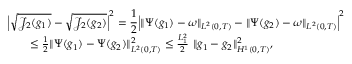Convert formula to latex. <formula><loc_0><loc_0><loc_500><loc_500>\begin{array} { r l r } { { \left | \sqrt { \mathcal { J } _ { 2 } ( g _ { 1 } ) } - \sqrt { \mathcal { J } _ { 2 } ( g _ { 2 } ) } \right | ^ { 2 } = \frac { 1 } { 2 } \left | \| \Psi ( g _ { 1 } ) - \omega \| _ { L ^ { 2 } ( 0 , T ) } - \| \Psi ( g _ { 2 } ) - \omega \| _ { L ^ { 2 } ( 0 , T ) } \right | ^ { 2 } } } \\ & { \leq \frac { 1 } { 2 } \| \Psi ( g _ { 1 } ) - \Psi ( g _ { 2 } ) \| _ { L ^ { 2 } ( 0 , T ) } ^ { 2 } \leq \frac { L _ { 1 } ^ { 2 } } { 2 } \ \| g _ { 1 } - g _ { 2 } \| _ { H ^ { 1 } ( 0 , T ) } ^ { 2 } , } \end{array}</formula> 